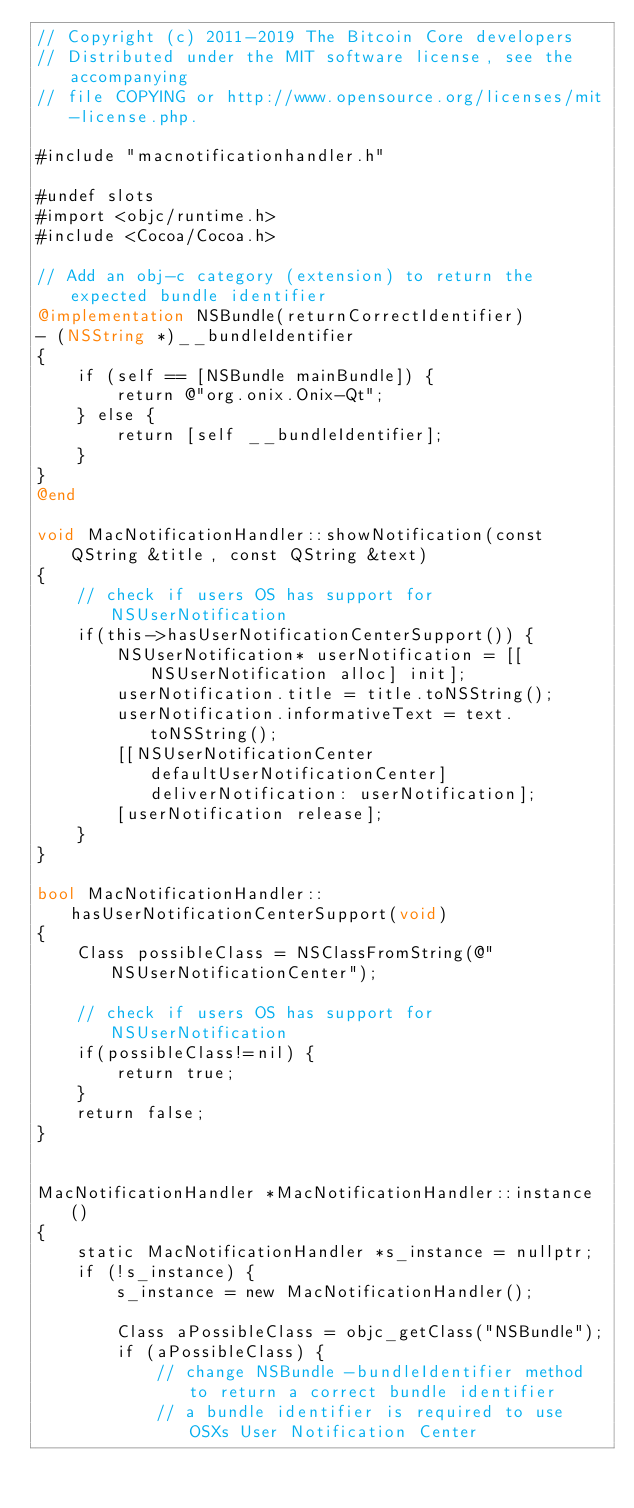<code> <loc_0><loc_0><loc_500><loc_500><_ObjectiveC_>// Copyright (c) 2011-2019 The Bitcoin Core developers
// Distributed under the MIT software license, see the accompanying
// file COPYING or http://www.opensource.org/licenses/mit-license.php.

#include "macnotificationhandler.h"

#undef slots
#import <objc/runtime.h>
#include <Cocoa/Cocoa.h>

// Add an obj-c category (extension) to return the expected bundle identifier
@implementation NSBundle(returnCorrectIdentifier)
- (NSString *)__bundleIdentifier
{
    if (self == [NSBundle mainBundle]) {
        return @"org.onix.Onix-Qt";
    } else {
        return [self __bundleIdentifier];
    }
}
@end

void MacNotificationHandler::showNotification(const QString &title, const QString &text)
{
    // check if users OS has support for NSUserNotification
    if(this->hasUserNotificationCenterSupport()) {
        NSUserNotification* userNotification = [[NSUserNotification alloc] init];
        userNotification.title = title.toNSString();
        userNotification.informativeText = text.toNSString();
        [[NSUserNotificationCenter defaultUserNotificationCenter] deliverNotification: userNotification];
        [userNotification release];
    }
}

bool MacNotificationHandler::hasUserNotificationCenterSupport(void)
{
    Class possibleClass = NSClassFromString(@"NSUserNotificationCenter");

    // check if users OS has support for NSUserNotification
    if(possibleClass!=nil) {
        return true;
    }
    return false;
}


MacNotificationHandler *MacNotificationHandler::instance()
{
    static MacNotificationHandler *s_instance = nullptr;
    if (!s_instance) {
        s_instance = new MacNotificationHandler();

        Class aPossibleClass = objc_getClass("NSBundle");
        if (aPossibleClass) {
            // change NSBundle -bundleIdentifier method to return a correct bundle identifier
            // a bundle identifier is required to use OSXs User Notification Center</code> 